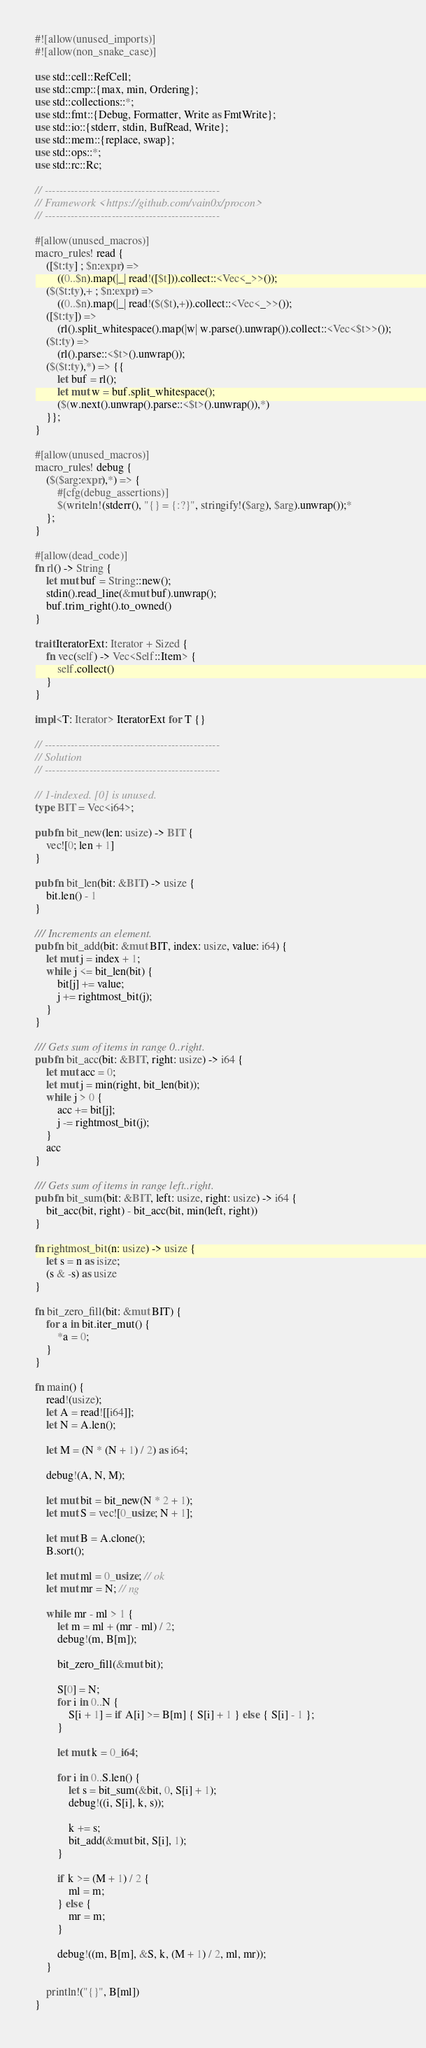Convert code to text. <code><loc_0><loc_0><loc_500><loc_500><_Rust_>#![allow(unused_imports)]
#![allow(non_snake_case)]

use std::cell::RefCell;
use std::cmp::{max, min, Ordering};
use std::collections::*;
use std::fmt::{Debug, Formatter, Write as FmtWrite};
use std::io::{stderr, stdin, BufRead, Write};
use std::mem::{replace, swap};
use std::ops::*;
use std::rc::Rc;

// -----------------------------------------------
// Framework <https://github.com/vain0x/procon>
// -----------------------------------------------

#[allow(unused_macros)]
macro_rules! read {
    ([$t:ty] ; $n:expr) =>
        ((0..$n).map(|_| read!([$t])).collect::<Vec<_>>());
    ($($t:ty),+ ; $n:expr) =>
        ((0..$n).map(|_| read!($($t),+)).collect::<Vec<_>>());
    ([$t:ty]) =>
        (rl().split_whitespace().map(|w| w.parse().unwrap()).collect::<Vec<$t>>());
    ($t:ty) =>
        (rl().parse::<$t>().unwrap());
    ($($t:ty),*) => {{
        let buf = rl();
        let mut w = buf.split_whitespace();
        ($(w.next().unwrap().parse::<$t>().unwrap()),*)
    }};
}

#[allow(unused_macros)]
macro_rules! debug {
    ($($arg:expr),*) => {
        #[cfg(debug_assertions)]
        $(writeln!(stderr(), "{} = {:?}", stringify!($arg), $arg).unwrap());*
    };
}

#[allow(dead_code)]
fn rl() -> String {
    let mut buf = String::new();
    stdin().read_line(&mut buf).unwrap();
    buf.trim_right().to_owned()
}

trait IteratorExt: Iterator + Sized {
    fn vec(self) -> Vec<Self::Item> {
        self.collect()
    }
}

impl<T: Iterator> IteratorExt for T {}

// -----------------------------------------------
// Solution
// -----------------------------------------------

// 1-indexed. [0] is unused.
type BIT = Vec<i64>;

pub fn bit_new(len: usize) -> BIT {
    vec![0; len + 1]
}

pub fn bit_len(bit: &BIT) -> usize {
    bit.len() - 1
}

/// Increments an element.
pub fn bit_add(bit: &mut BIT, index: usize, value: i64) {
    let mut j = index + 1;
    while j <= bit_len(bit) {
        bit[j] += value;
        j += rightmost_bit(j);
    }
}

/// Gets sum of items in range 0..right.
pub fn bit_acc(bit: &BIT, right: usize) -> i64 {
    let mut acc = 0;
    let mut j = min(right, bit_len(bit));
    while j > 0 {
        acc += bit[j];
        j -= rightmost_bit(j);
    }
    acc
}

/// Gets sum of items in range left..right.
pub fn bit_sum(bit: &BIT, left: usize, right: usize) -> i64 {
    bit_acc(bit, right) - bit_acc(bit, min(left, right))
}

fn rightmost_bit(n: usize) -> usize {
    let s = n as isize;
    (s & -s) as usize
}

fn bit_zero_fill(bit: &mut BIT) {
    for a in bit.iter_mut() {
        *a = 0;
    }
}

fn main() {
    read!(usize);
    let A = read![[i64]];
    let N = A.len();

    let M = (N * (N + 1) / 2) as i64;

    debug!(A, N, M);

    let mut bit = bit_new(N * 2 + 1);
    let mut S = vec![0_usize; N + 1];

    let mut B = A.clone();
    B.sort();

    let mut ml = 0_usize; // ok
    let mut mr = N; // ng

    while mr - ml > 1 {
        let m = ml + (mr - ml) / 2;
        debug!(m, B[m]);

        bit_zero_fill(&mut bit);

        S[0] = N;
        for i in 0..N {
            S[i + 1] = if A[i] >= B[m] { S[i] + 1 } else { S[i] - 1 };
        }

        let mut k = 0_i64;

        for i in 0..S.len() {
            let s = bit_sum(&bit, 0, S[i] + 1);
            debug!((i, S[i], k, s));

            k += s;
            bit_add(&mut bit, S[i], 1);
        }

        if k >= (M + 1) / 2 {
            ml = m;
        } else {
            mr = m;
        }

        debug!((m, B[m], &S, k, (M + 1) / 2, ml, mr));
    }

    println!("{}", B[ml])
}
</code> 